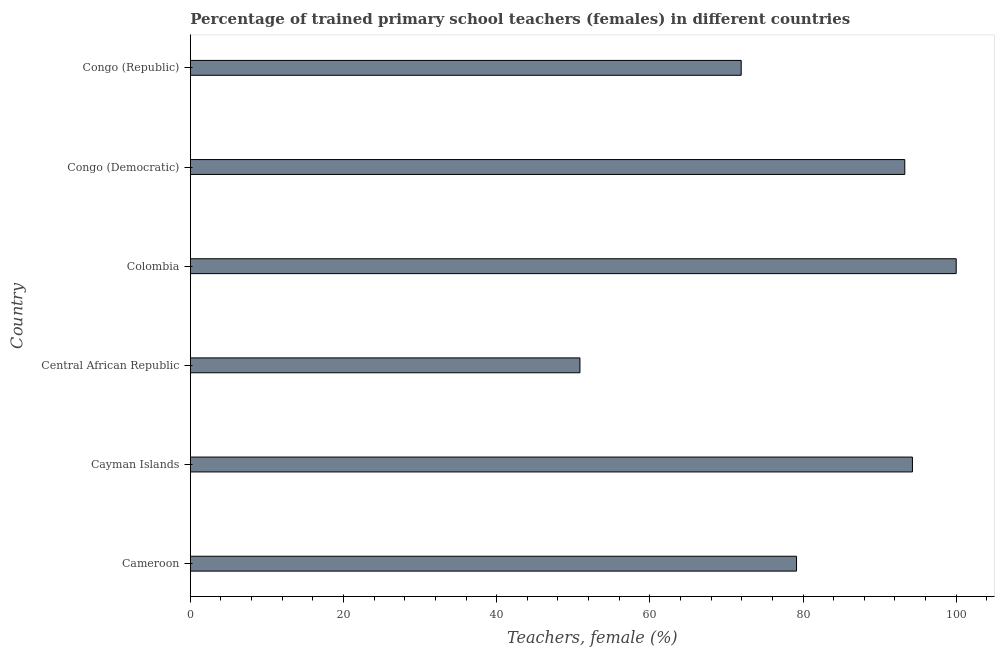What is the title of the graph?
Offer a terse response. Percentage of trained primary school teachers (females) in different countries. What is the label or title of the X-axis?
Ensure brevity in your answer.  Teachers, female (%). What is the label or title of the Y-axis?
Your answer should be compact. Country. What is the percentage of trained female teachers in Central African Republic?
Ensure brevity in your answer.  50.88. Across all countries, what is the maximum percentage of trained female teachers?
Your answer should be compact. 100. Across all countries, what is the minimum percentage of trained female teachers?
Give a very brief answer. 50.88. In which country was the percentage of trained female teachers minimum?
Provide a succinct answer. Central African Republic. What is the sum of the percentage of trained female teachers?
Provide a succinct answer. 489.53. What is the difference between the percentage of trained female teachers in Cameroon and Congo (Democratic)?
Give a very brief answer. -14.13. What is the average percentage of trained female teachers per country?
Your answer should be compact. 81.59. What is the median percentage of trained female teachers?
Your response must be concise. 86.22. What is the ratio of the percentage of trained female teachers in Cayman Islands to that in Central African Republic?
Your answer should be very brief. 1.85. What is the difference between the highest and the second highest percentage of trained female teachers?
Keep it short and to the point. 5.71. Is the sum of the percentage of trained female teachers in Central African Republic and Congo (Republic) greater than the maximum percentage of trained female teachers across all countries?
Your response must be concise. Yes. What is the difference between the highest and the lowest percentage of trained female teachers?
Offer a terse response. 49.12. In how many countries, is the percentage of trained female teachers greater than the average percentage of trained female teachers taken over all countries?
Offer a very short reply. 3. Are all the bars in the graph horizontal?
Your answer should be very brief. Yes. How many countries are there in the graph?
Your answer should be compact. 6. What is the Teachers, female (%) of Cameroon?
Provide a short and direct response. 79.15. What is the Teachers, female (%) in Cayman Islands?
Keep it short and to the point. 94.29. What is the Teachers, female (%) in Central African Republic?
Your answer should be compact. 50.88. What is the Teachers, female (%) in Colombia?
Keep it short and to the point. 100. What is the Teachers, female (%) in Congo (Democratic)?
Provide a short and direct response. 93.29. What is the Teachers, female (%) in Congo (Republic)?
Provide a short and direct response. 71.93. What is the difference between the Teachers, female (%) in Cameroon and Cayman Islands?
Your answer should be compact. -15.13. What is the difference between the Teachers, female (%) in Cameroon and Central African Republic?
Offer a very short reply. 28.28. What is the difference between the Teachers, female (%) in Cameroon and Colombia?
Your answer should be very brief. -20.85. What is the difference between the Teachers, female (%) in Cameroon and Congo (Democratic)?
Give a very brief answer. -14.13. What is the difference between the Teachers, female (%) in Cameroon and Congo (Republic)?
Provide a short and direct response. 7.22. What is the difference between the Teachers, female (%) in Cayman Islands and Central African Republic?
Provide a short and direct response. 43.41. What is the difference between the Teachers, female (%) in Cayman Islands and Colombia?
Give a very brief answer. -5.71. What is the difference between the Teachers, female (%) in Cayman Islands and Congo (Democratic)?
Offer a very short reply. 1. What is the difference between the Teachers, female (%) in Cayman Islands and Congo (Republic)?
Your answer should be very brief. 22.36. What is the difference between the Teachers, female (%) in Central African Republic and Colombia?
Make the answer very short. -49.12. What is the difference between the Teachers, female (%) in Central African Republic and Congo (Democratic)?
Make the answer very short. -42.41. What is the difference between the Teachers, female (%) in Central African Republic and Congo (Republic)?
Your answer should be compact. -21.05. What is the difference between the Teachers, female (%) in Colombia and Congo (Democratic)?
Your answer should be compact. 6.71. What is the difference between the Teachers, female (%) in Colombia and Congo (Republic)?
Provide a short and direct response. 28.07. What is the difference between the Teachers, female (%) in Congo (Democratic) and Congo (Republic)?
Your answer should be very brief. 21.36. What is the ratio of the Teachers, female (%) in Cameroon to that in Cayman Islands?
Offer a terse response. 0.84. What is the ratio of the Teachers, female (%) in Cameroon to that in Central African Republic?
Give a very brief answer. 1.56. What is the ratio of the Teachers, female (%) in Cameroon to that in Colombia?
Provide a short and direct response. 0.79. What is the ratio of the Teachers, female (%) in Cameroon to that in Congo (Democratic)?
Provide a succinct answer. 0.85. What is the ratio of the Teachers, female (%) in Cameroon to that in Congo (Republic)?
Provide a succinct answer. 1.1. What is the ratio of the Teachers, female (%) in Cayman Islands to that in Central African Republic?
Ensure brevity in your answer.  1.85. What is the ratio of the Teachers, female (%) in Cayman Islands to that in Colombia?
Provide a succinct answer. 0.94. What is the ratio of the Teachers, female (%) in Cayman Islands to that in Congo (Republic)?
Make the answer very short. 1.31. What is the ratio of the Teachers, female (%) in Central African Republic to that in Colombia?
Your response must be concise. 0.51. What is the ratio of the Teachers, female (%) in Central African Republic to that in Congo (Democratic)?
Your answer should be compact. 0.55. What is the ratio of the Teachers, female (%) in Central African Republic to that in Congo (Republic)?
Make the answer very short. 0.71. What is the ratio of the Teachers, female (%) in Colombia to that in Congo (Democratic)?
Ensure brevity in your answer.  1.07. What is the ratio of the Teachers, female (%) in Colombia to that in Congo (Republic)?
Give a very brief answer. 1.39. What is the ratio of the Teachers, female (%) in Congo (Democratic) to that in Congo (Republic)?
Make the answer very short. 1.3. 